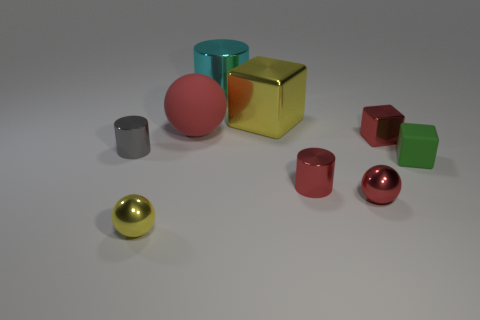Is there anything else that has the same size as the yellow metal block?
Ensure brevity in your answer.  Yes. There is a tiny cube that is the same material as the cyan cylinder; what is its color?
Offer a very short reply. Red. There is a tiny metal cylinder in front of the green matte block; is it the same color as the ball behind the tiny rubber cube?
Give a very brief answer. Yes. What number of cubes are red shiny objects or small matte things?
Provide a succinct answer. 2. Are there an equal number of tiny metal objects that are to the right of the big yellow metallic thing and small cylinders?
Offer a terse response. No. What is the yellow thing behind the small red metal object in front of the tiny cylinder that is right of the big rubber sphere made of?
Provide a short and direct response. Metal. What is the material of the small ball that is the same color as the large metal block?
Your response must be concise. Metal. What number of objects are shiny objects in front of the tiny green matte thing or big metallic things?
Provide a succinct answer. 5. How many things are big cyan rubber spheres or metallic cylinders that are in front of the small green thing?
Your response must be concise. 1. There is a large shiny cylinder on the right side of the rubber thing behind the small green block; what number of yellow objects are behind it?
Keep it short and to the point. 0. 